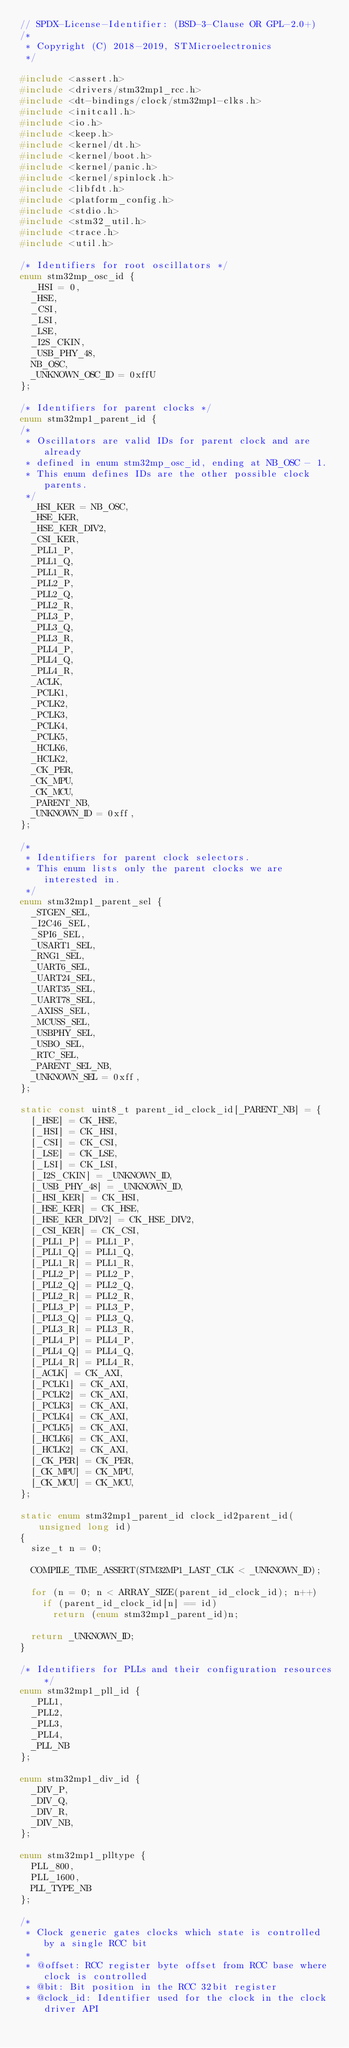Convert code to text. <code><loc_0><loc_0><loc_500><loc_500><_C_>// SPDX-License-Identifier: (BSD-3-Clause OR GPL-2.0+)
/*
 * Copyright (C) 2018-2019, STMicroelectronics
 */

#include <assert.h>
#include <drivers/stm32mp1_rcc.h>
#include <dt-bindings/clock/stm32mp1-clks.h>
#include <initcall.h>
#include <io.h>
#include <keep.h>
#include <kernel/dt.h>
#include <kernel/boot.h>
#include <kernel/panic.h>
#include <kernel/spinlock.h>
#include <libfdt.h>
#include <platform_config.h>
#include <stdio.h>
#include <stm32_util.h>
#include <trace.h>
#include <util.h>

/* Identifiers for root oscillators */
enum stm32mp_osc_id {
	_HSI = 0,
	_HSE,
	_CSI,
	_LSI,
	_LSE,
	_I2S_CKIN,
	_USB_PHY_48,
	NB_OSC,
	_UNKNOWN_OSC_ID = 0xffU
};

/* Identifiers for parent clocks */
enum stm32mp1_parent_id {
/*
 * Oscillators are valid IDs for parent clock and are already
 * defined in enum stm32mp_osc_id, ending at NB_OSC - 1.
 * This enum defines IDs are the other possible clock parents.
 */
	_HSI_KER = NB_OSC,
	_HSE_KER,
	_HSE_KER_DIV2,
	_CSI_KER,
	_PLL1_P,
	_PLL1_Q,
	_PLL1_R,
	_PLL2_P,
	_PLL2_Q,
	_PLL2_R,
	_PLL3_P,
	_PLL3_Q,
	_PLL3_R,
	_PLL4_P,
	_PLL4_Q,
	_PLL4_R,
	_ACLK,
	_PCLK1,
	_PCLK2,
	_PCLK3,
	_PCLK4,
	_PCLK5,
	_HCLK6,
	_HCLK2,
	_CK_PER,
	_CK_MPU,
	_CK_MCU,
	_PARENT_NB,
	_UNKNOWN_ID = 0xff,
};

/*
 * Identifiers for parent clock selectors.
 * This enum lists only the parent clocks we are interested in.
 */
enum stm32mp1_parent_sel {
	_STGEN_SEL,
	_I2C46_SEL,
	_SPI6_SEL,
	_USART1_SEL,
	_RNG1_SEL,
	_UART6_SEL,
	_UART24_SEL,
	_UART35_SEL,
	_UART78_SEL,
	_AXISS_SEL,
	_MCUSS_SEL,
	_USBPHY_SEL,
	_USBO_SEL,
	_RTC_SEL,
	_PARENT_SEL_NB,
	_UNKNOWN_SEL = 0xff,
};

static const uint8_t parent_id_clock_id[_PARENT_NB] = {
	[_HSE] = CK_HSE,
	[_HSI] = CK_HSI,
	[_CSI] = CK_CSI,
	[_LSE] = CK_LSE,
	[_LSI] = CK_LSI,
	[_I2S_CKIN] = _UNKNOWN_ID,
	[_USB_PHY_48] = _UNKNOWN_ID,
	[_HSI_KER] = CK_HSI,
	[_HSE_KER] = CK_HSE,
	[_HSE_KER_DIV2] = CK_HSE_DIV2,
	[_CSI_KER] = CK_CSI,
	[_PLL1_P] = PLL1_P,
	[_PLL1_Q] = PLL1_Q,
	[_PLL1_R] = PLL1_R,
	[_PLL2_P] = PLL2_P,
	[_PLL2_Q] = PLL2_Q,
	[_PLL2_R] = PLL2_R,
	[_PLL3_P] = PLL3_P,
	[_PLL3_Q] = PLL3_Q,
	[_PLL3_R] = PLL3_R,
	[_PLL4_P] = PLL4_P,
	[_PLL4_Q] = PLL4_Q,
	[_PLL4_R] = PLL4_R,
	[_ACLK] = CK_AXI,
	[_PCLK1] = CK_AXI,
	[_PCLK2] = CK_AXI,
	[_PCLK3] = CK_AXI,
	[_PCLK4] = CK_AXI,
	[_PCLK5] = CK_AXI,
	[_HCLK6] = CK_AXI,
	[_HCLK2] = CK_AXI,
	[_CK_PER] = CK_PER,
	[_CK_MPU] = CK_MPU,
	[_CK_MCU] = CK_MCU,
};

static enum stm32mp1_parent_id clock_id2parent_id(unsigned long id)
{
	size_t n = 0;

	COMPILE_TIME_ASSERT(STM32MP1_LAST_CLK < _UNKNOWN_ID);

	for (n = 0; n < ARRAY_SIZE(parent_id_clock_id); n++)
		if (parent_id_clock_id[n] == id)
			return (enum stm32mp1_parent_id)n;

	return _UNKNOWN_ID;
}

/* Identifiers for PLLs and their configuration resources */
enum stm32mp1_pll_id {
	_PLL1,
	_PLL2,
	_PLL3,
	_PLL4,
	_PLL_NB
};

enum stm32mp1_div_id {
	_DIV_P,
	_DIV_Q,
	_DIV_R,
	_DIV_NB,
};

enum stm32mp1_plltype {
	PLL_800,
	PLL_1600,
	PLL_TYPE_NB
};

/*
 * Clock generic gates clocks which state is controlled by a single RCC bit
 *
 * @offset: RCC register byte offset from RCC base where clock is controlled
 * @bit: Bit position in the RCC 32bit register
 * @clock_id: Identifier used for the clock in the clock driver API</code> 